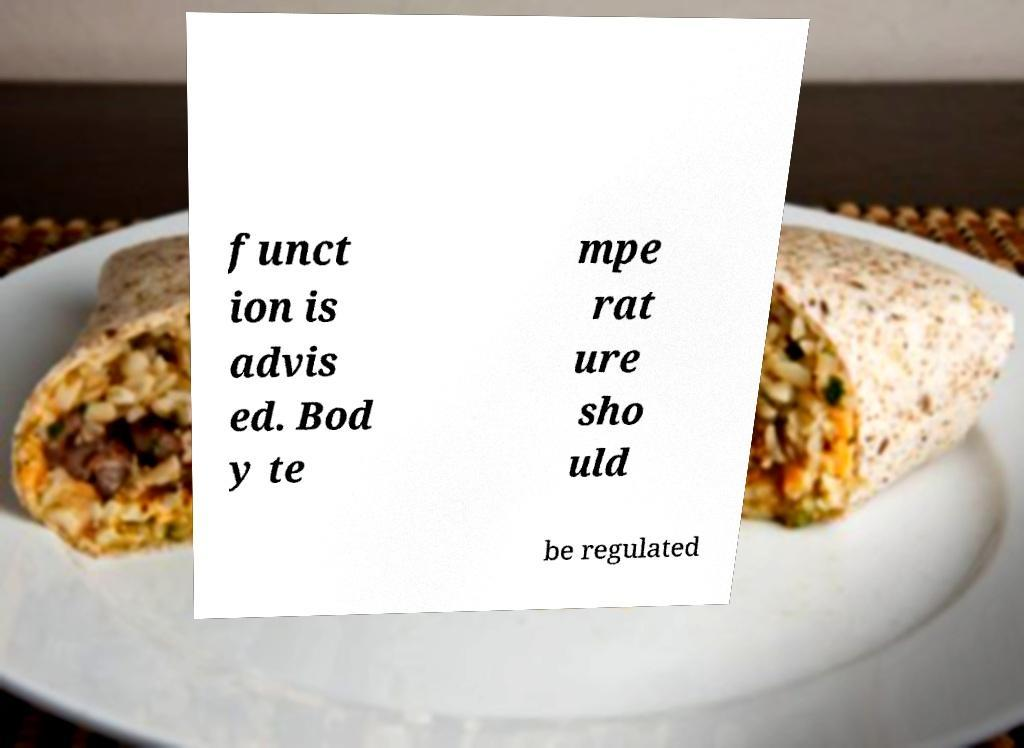Please read and relay the text visible in this image. What does it say? funct ion is advis ed. Bod y te mpe rat ure sho uld be regulated 